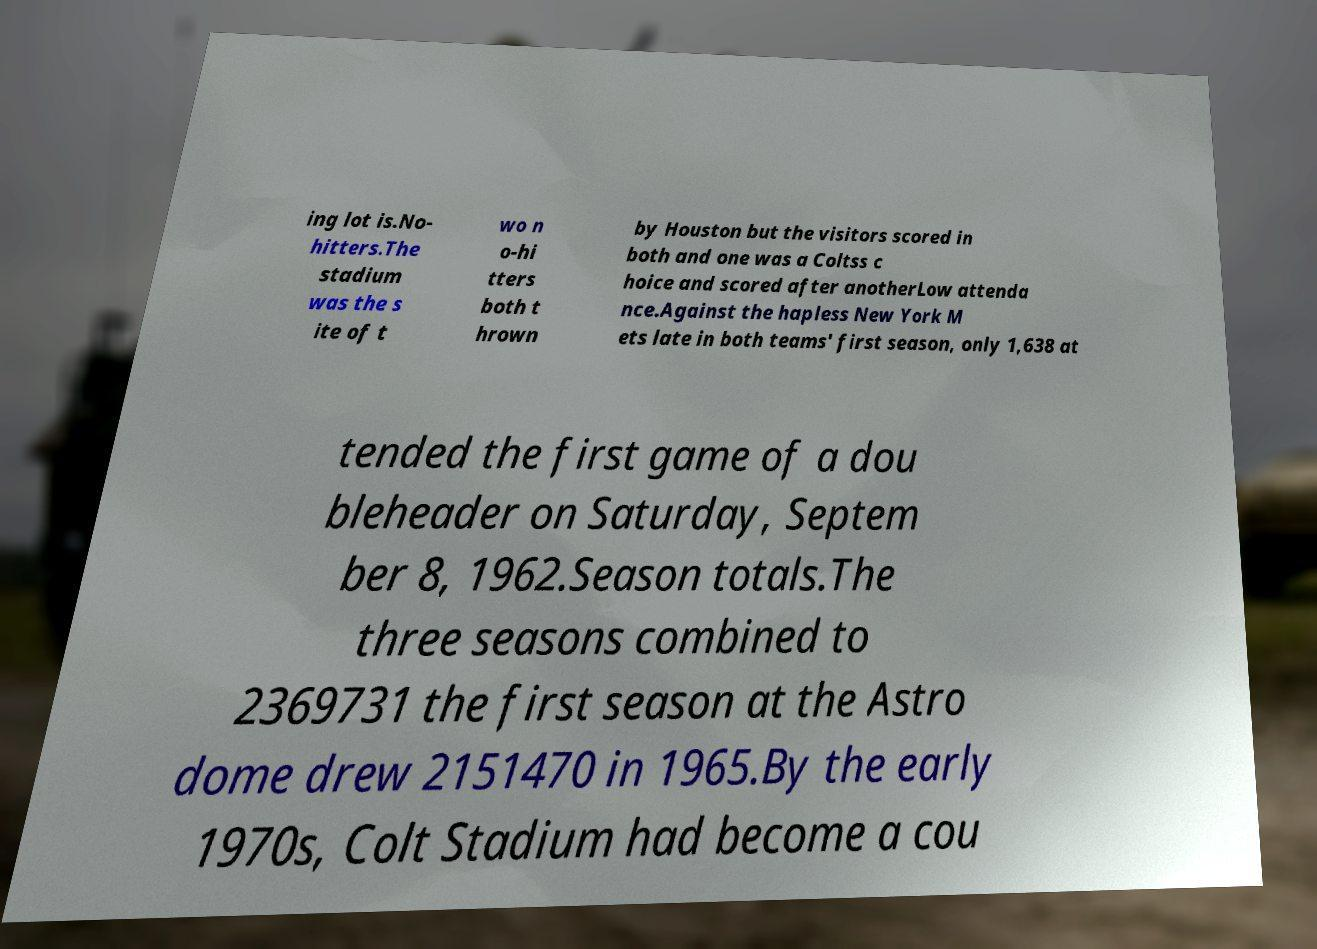Could you assist in decoding the text presented in this image and type it out clearly? ing lot is.No- hitters.The stadium was the s ite of t wo n o-hi tters both t hrown by Houston but the visitors scored in both and one was a Coltss c hoice and scored after anotherLow attenda nce.Against the hapless New York M ets late in both teams' first season, only 1,638 at tended the first game of a dou bleheader on Saturday, Septem ber 8, 1962.Season totals.The three seasons combined to 2369731 the first season at the Astro dome drew 2151470 in 1965.By the early 1970s, Colt Stadium had become a cou 